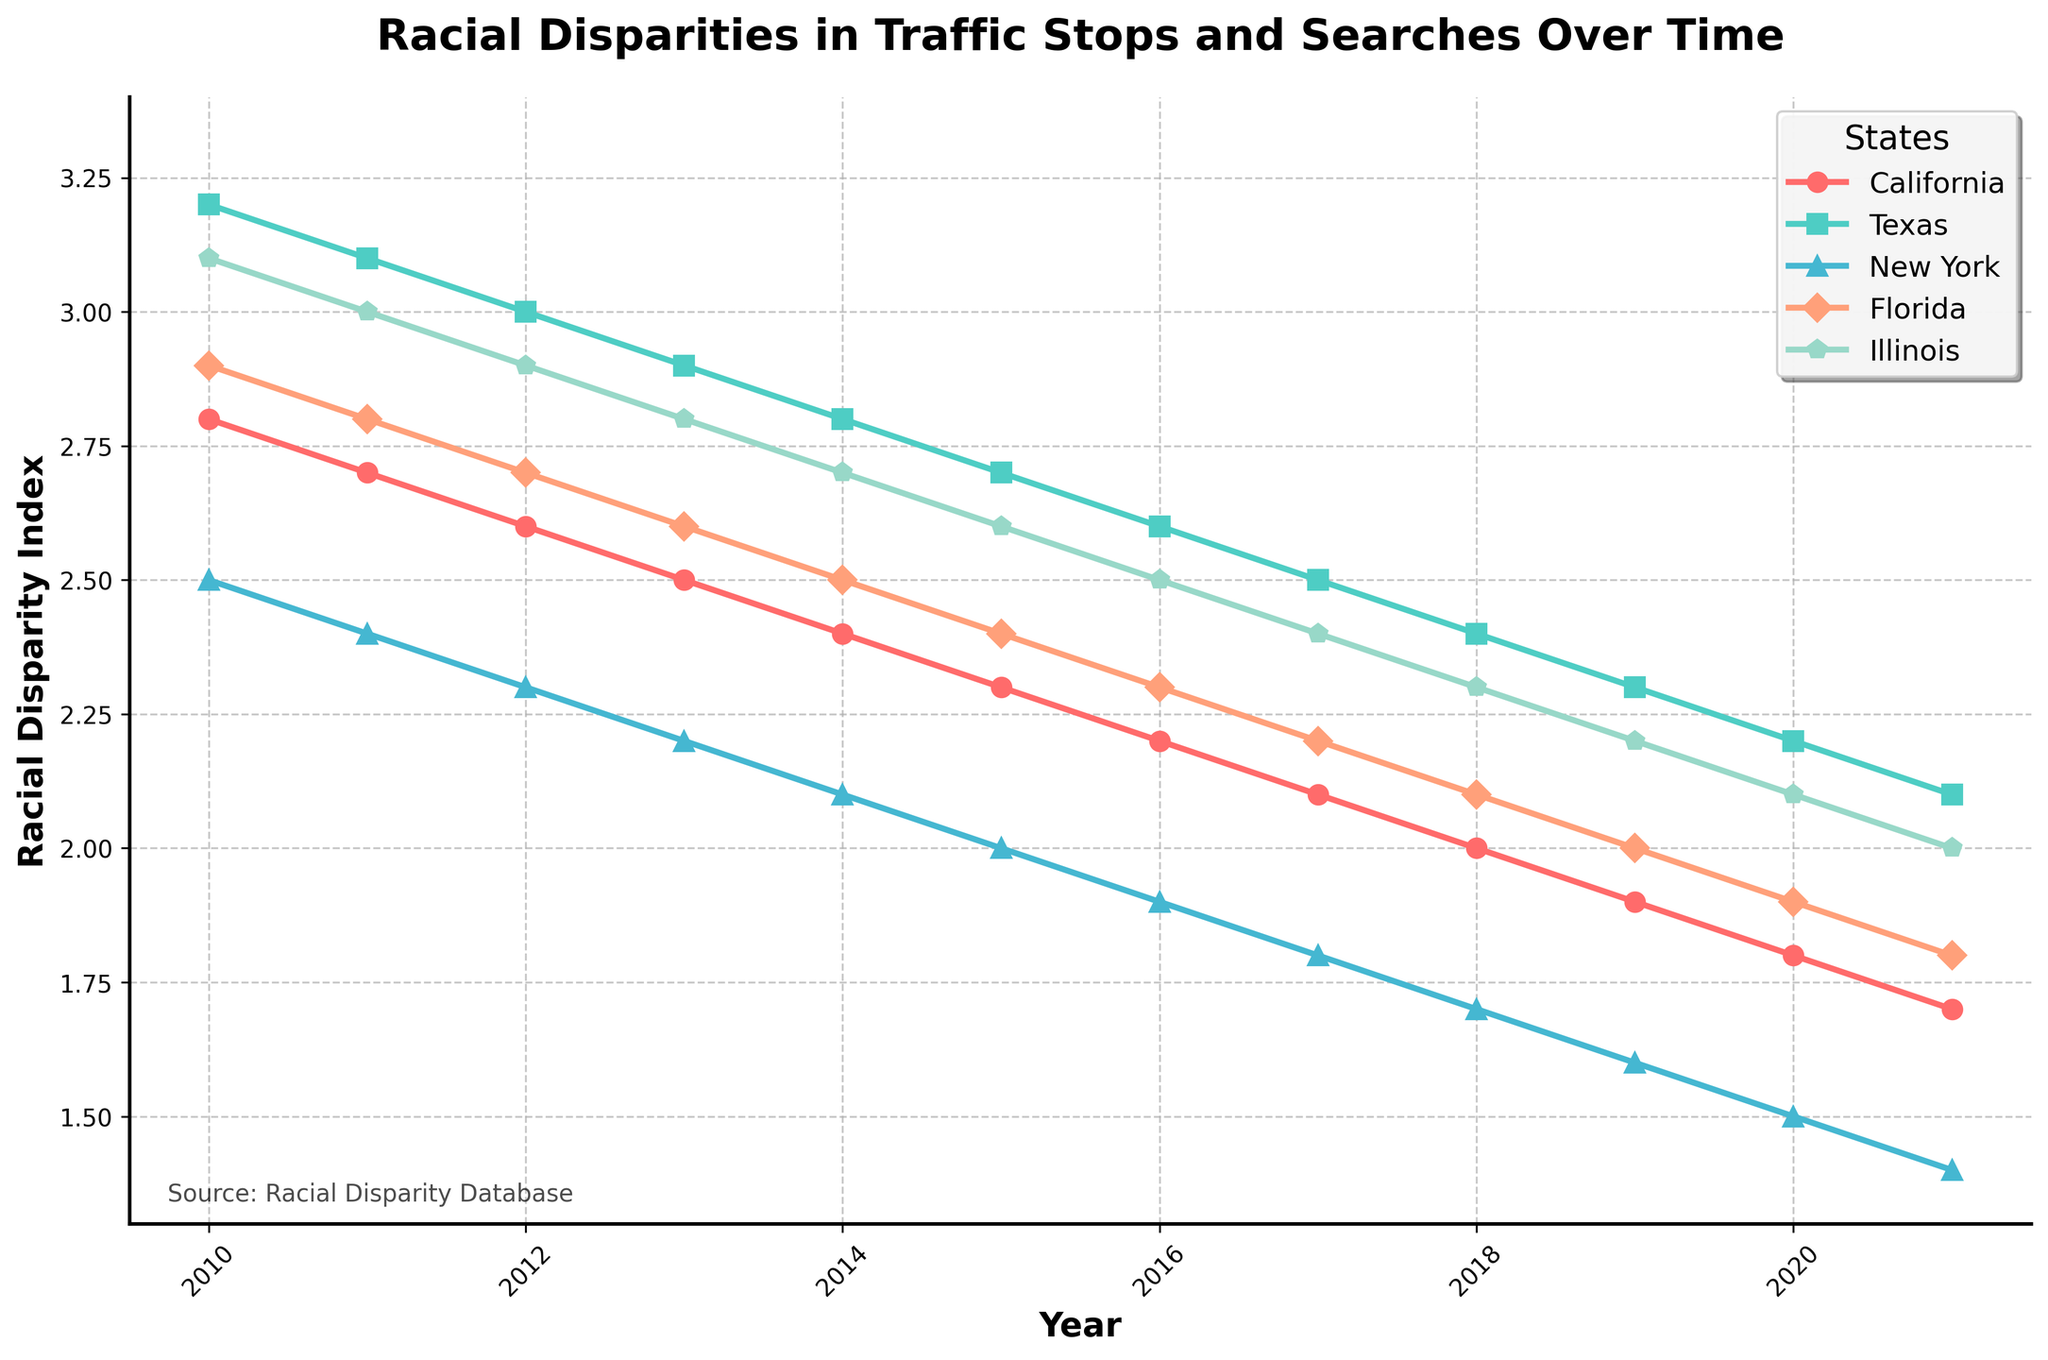What is the general trend of racial disparity index in California from 2010 to 2021? By looking at the plot, note the relative heights of the markers for California, consistently decreasing year by year. This trend shows a gradual decline over the years.
Answer: Gradual decline Which state had the highest racial disparity index in 2014? By comparing the heights of the markers for all the states in 2014, identify the tallest marker which corresponds to Texas.
Answer: Texas What is the approximate difference in the racial disparity index between New York and Illinois in 2017? Locate the markers for New York and Illinois in 2017, and calculate the difference between the values (2.4 - 1.8 = 0.6).
Answer: 0.6 Which state's racial disparity index reduced the most from 2010 to 2021? By calculating the reduction for each state over the given period and comparing: California (2.8-1.7=1.1), Texas (3.2-2.1=1.1), New York (2.5-1.4=1.1), Florida (2.9-1.8=1.1), Illinois (3.1-2.0=1.1). All states show equal reduction.
Answer: California, Texas, New York, Florida, Illinois What was the average racial disparity index in 2015 across all five states? Sum the values for 2015 (2.3 + 2.7 + 2.0 + 2.4 + 2.6 = 12.0) and divide by the number of states (5).
Answer: 2.4 In which year did Texas exhibit a racial disparity index of 2.2? Locate the marker on Texas's line that is at 2.2 on the y-axis and match it to the corresponding year on the x-axis, which is 2020.
Answer: 2020 By how much did Florida’s racial disparity index decrease from 2017 to 2019? Subtract Florida's value in 2019 from its value in 2017 (2.2 - 2.0 = 0.2).
Answer: 0.2 Which state shows the smallest fluctuation in its racial disparity index from 2010 to 2021? Calculate the range (difference between the maximum and minimum value) for each state and compare: California (2.8-1.7=1.1), Texas (3.2-2.1=1.1), New York (2.5-1.4=1.1), Florida (2.9-1.8=1.1), Illinois (3.1-2.0=1.1). All states show equal fluctuation.
Answer: California, Texas, New York, Florida, Illinois 